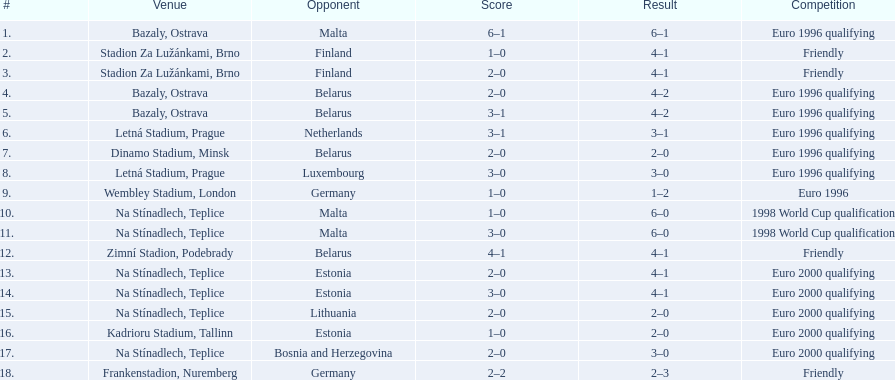Which team did czech republic score the most goals against? Malta. 